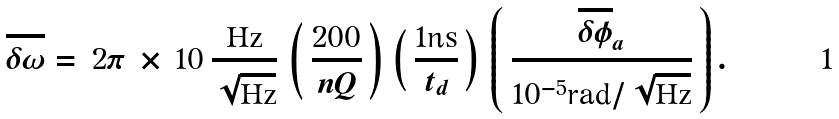<formula> <loc_0><loc_0><loc_500><loc_500>\overline { \delta \omega } = \, 2 \pi \, \times \, 1 0 \, \frac { \text {Hz} } { \sqrt { \text {Hz} } } \, \left ( \, \frac { 2 0 0 } { n Q } \, \right ) \, \left ( \, \frac { 1 \text {ns} } { t _ { d } } \, \right ) \, \left ( \, \frac { \overline { \delta \phi } _ { a } } { 1 0 ^ { - 5 } \text {rad} / \sqrt { \text {Hz} } } \, \right ) .</formula> 